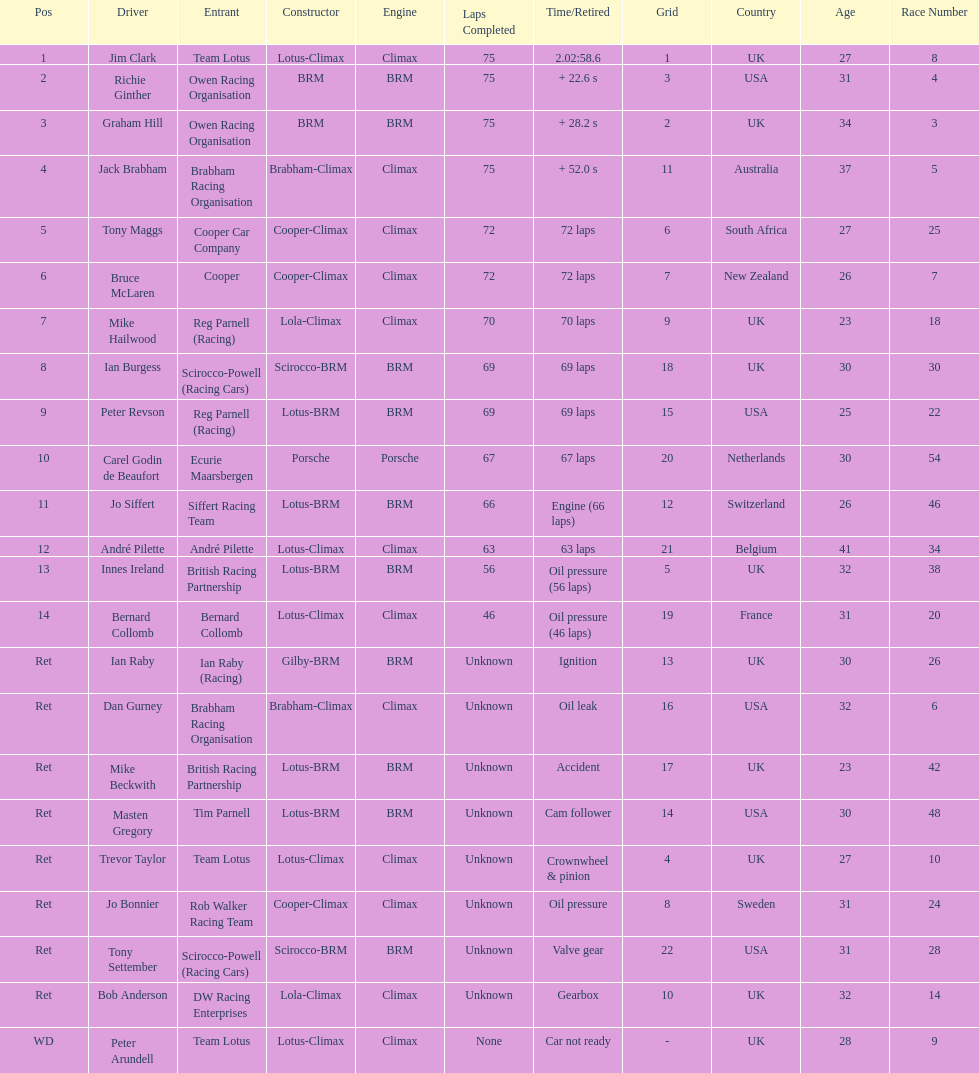How many different drivers are listed? 23. 